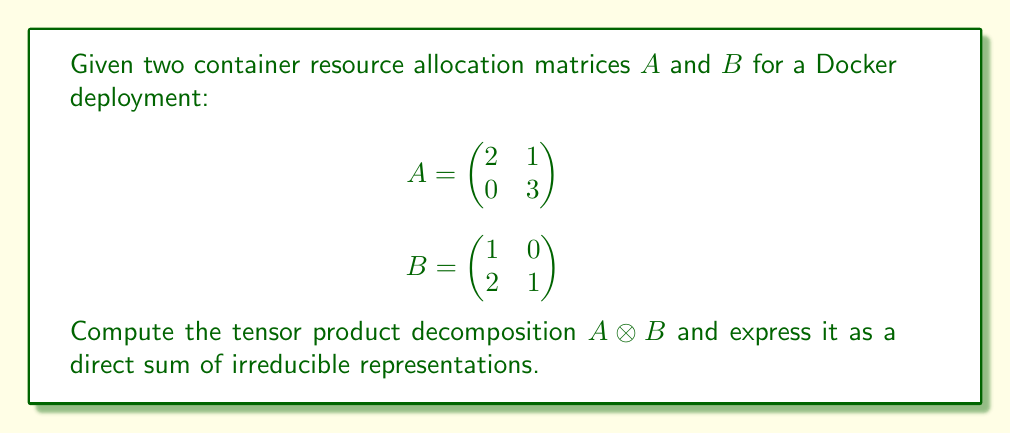Solve this math problem. To solve this problem, we'll follow these steps:

1. Calculate the tensor product $A \otimes B$:
   $$A \otimes B = \begin{pmatrix}
   2 \begin{pmatrix} 1 & 0 \\ 2 & 1 \end{pmatrix} & 1 \begin{pmatrix} 1 & 0 \\ 2 & 1 \end{pmatrix} \\
   0 \begin{pmatrix} 1 & 0 \\ 2 & 1 \end{pmatrix} & 3 \begin{pmatrix} 1 & 0 \\ 2 & 1 \end{pmatrix}
   \end{pmatrix}$$

   $$= \begin{pmatrix}
   2 & 0 & 1 & 0 \\
   4 & 2 & 2 & 1 \\
   0 & 0 & 3 & 0 \\
   0 & 0 & 6 & 3
   \end{pmatrix}$$

2. Find the eigenvalues of $A \otimes B$:
   Characteristic polynomial: $\det(A \otimes B - \lambda I) = \lambda^4 - 8\lambda^3 + 18\lambda^2 - 12\lambda$
   Eigenvalues: $\lambda_1 = 0$, $\lambda_2 = 2$, $\lambda_3 = 3$, $\lambda_4 = 3$

3. Determine the Jordan canonical form:
   The matrix has three distinct eigenvalues, so its Jordan canonical form is:
   $$J = \begin{pmatrix}
   0 & 0 & 0 & 0 \\
   0 & 2 & 0 & 0 \\
   0 & 0 & 3 & 0 \\
   0 & 0 & 0 & 3
   \end{pmatrix}$$

4. Express as a direct sum of irreducible representations:
   Each Jordan block corresponds to an irreducible representation.
   - $0$ corresponds to the trivial representation $V_0$
   - $2$ corresponds to a 1-dimensional representation $V_2$
   - $3$ corresponds to a 2-dimensional representation $V_3$

Therefore, the tensor product decomposition can be expressed as:
$A \otimes B \cong V_0 \oplus V_2 \oplus V_3$
Answer: $V_0 \oplus V_2 \oplus V_3$ 